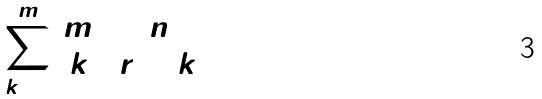<formula> <loc_0><loc_0><loc_500><loc_500>\sum _ { k = 0 } ^ { m } ( \begin{matrix} m \\ k \end{matrix} ) ( \begin{matrix} n \\ r + k \end{matrix} )</formula> 